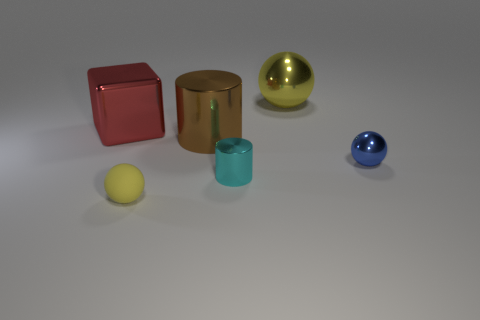Add 1 shiny things. How many objects exist? 7 Subtract all cylinders. How many objects are left? 4 Add 1 red things. How many red things exist? 2 Subtract 1 blue balls. How many objects are left? 5 Subtract all big brown metallic cylinders. Subtract all gray rubber cylinders. How many objects are left? 5 Add 1 small matte balls. How many small matte balls are left? 2 